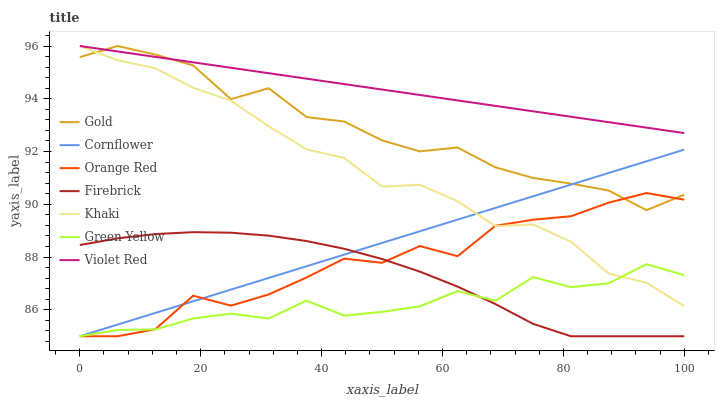Does Green Yellow have the minimum area under the curve?
Answer yes or no. Yes. Does Violet Red have the maximum area under the curve?
Answer yes or no. Yes. Does Khaki have the minimum area under the curve?
Answer yes or no. No. Does Khaki have the maximum area under the curve?
Answer yes or no. No. Is Violet Red the smoothest?
Answer yes or no. Yes. Is Gold the roughest?
Answer yes or no. Yes. Is Khaki the smoothest?
Answer yes or no. No. Is Khaki the roughest?
Answer yes or no. No. Does Khaki have the lowest value?
Answer yes or no. No. Does Gold have the highest value?
Answer yes or no. Yes. Does Firebrick have the highest value?
Answer yes or no. No. Is Firebrick less than Khaki?
Answer yes or no. Yes. Is Violet Red greater than Green Yellow?
Answer yes or no. Yes. Does Firebrick intersect Khaki?
Answer yes or no. No. 